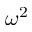Convert formula to latex. <formula><loc_0><loc_0><loc_500><loc_500>\omega ^ { 2 }</formula> 